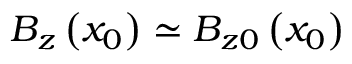Convert formula to latex. <formula><loc_0><loc_0><loc_500><loc_500>B _ { z } \left ( x _ { 0 } \right ) \simeq B _ { z 0 } \left ( x _ { 0 } \right )</formula> 